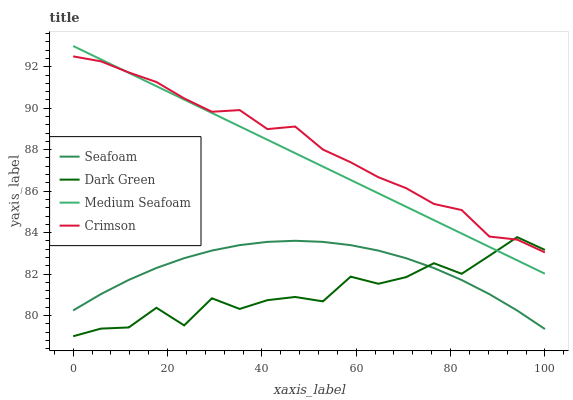Does Dark Green have the minimum area under the curve?
Answer yes or no. Yes. Does Crimson have the maximum area under the curve?
Answer yes or no. Yes. Does Medium Seafoam have the minimum area under the curve?
Answer yes or no. No. Does Medium Seafoam have the maximum area under the curve?
Answer yes or no. No. Is Medium Seafoam the smoothest?
Answer yes or no. Yes. Is Dark Green the roughest?
Answer yes or no. Yes. Is Seafoam the smoothest?
Answer yes or no. No. Is Seafoam the roughest?
Answer yes or no. No. Does Dark Green have the lowest value?
Answer yes or no. Yes. Does Medium Seafoam have the lowest value?
Answer yes or no. No. Does Medium Seafoam have the highest value?
Answer yes or no. Yes. Does Seafoam have the highest value?
Answer yes or no. No. Is Seafoam less than Medium Seafoam?
Answer yes or no. Yes. Is Crimson greater than Seafoam?
Answer yes or no. Yes. Does Dark Green intersect Crimson?
Answer yes or no. Yes. Is Dark Green less than Crimson?
Answer yes or no. No. Is Dark Green greater than Crimson?
Answer yes or no. No. Does Seafoam intersect Medium Seafoam?
Answer yes or no. No. 